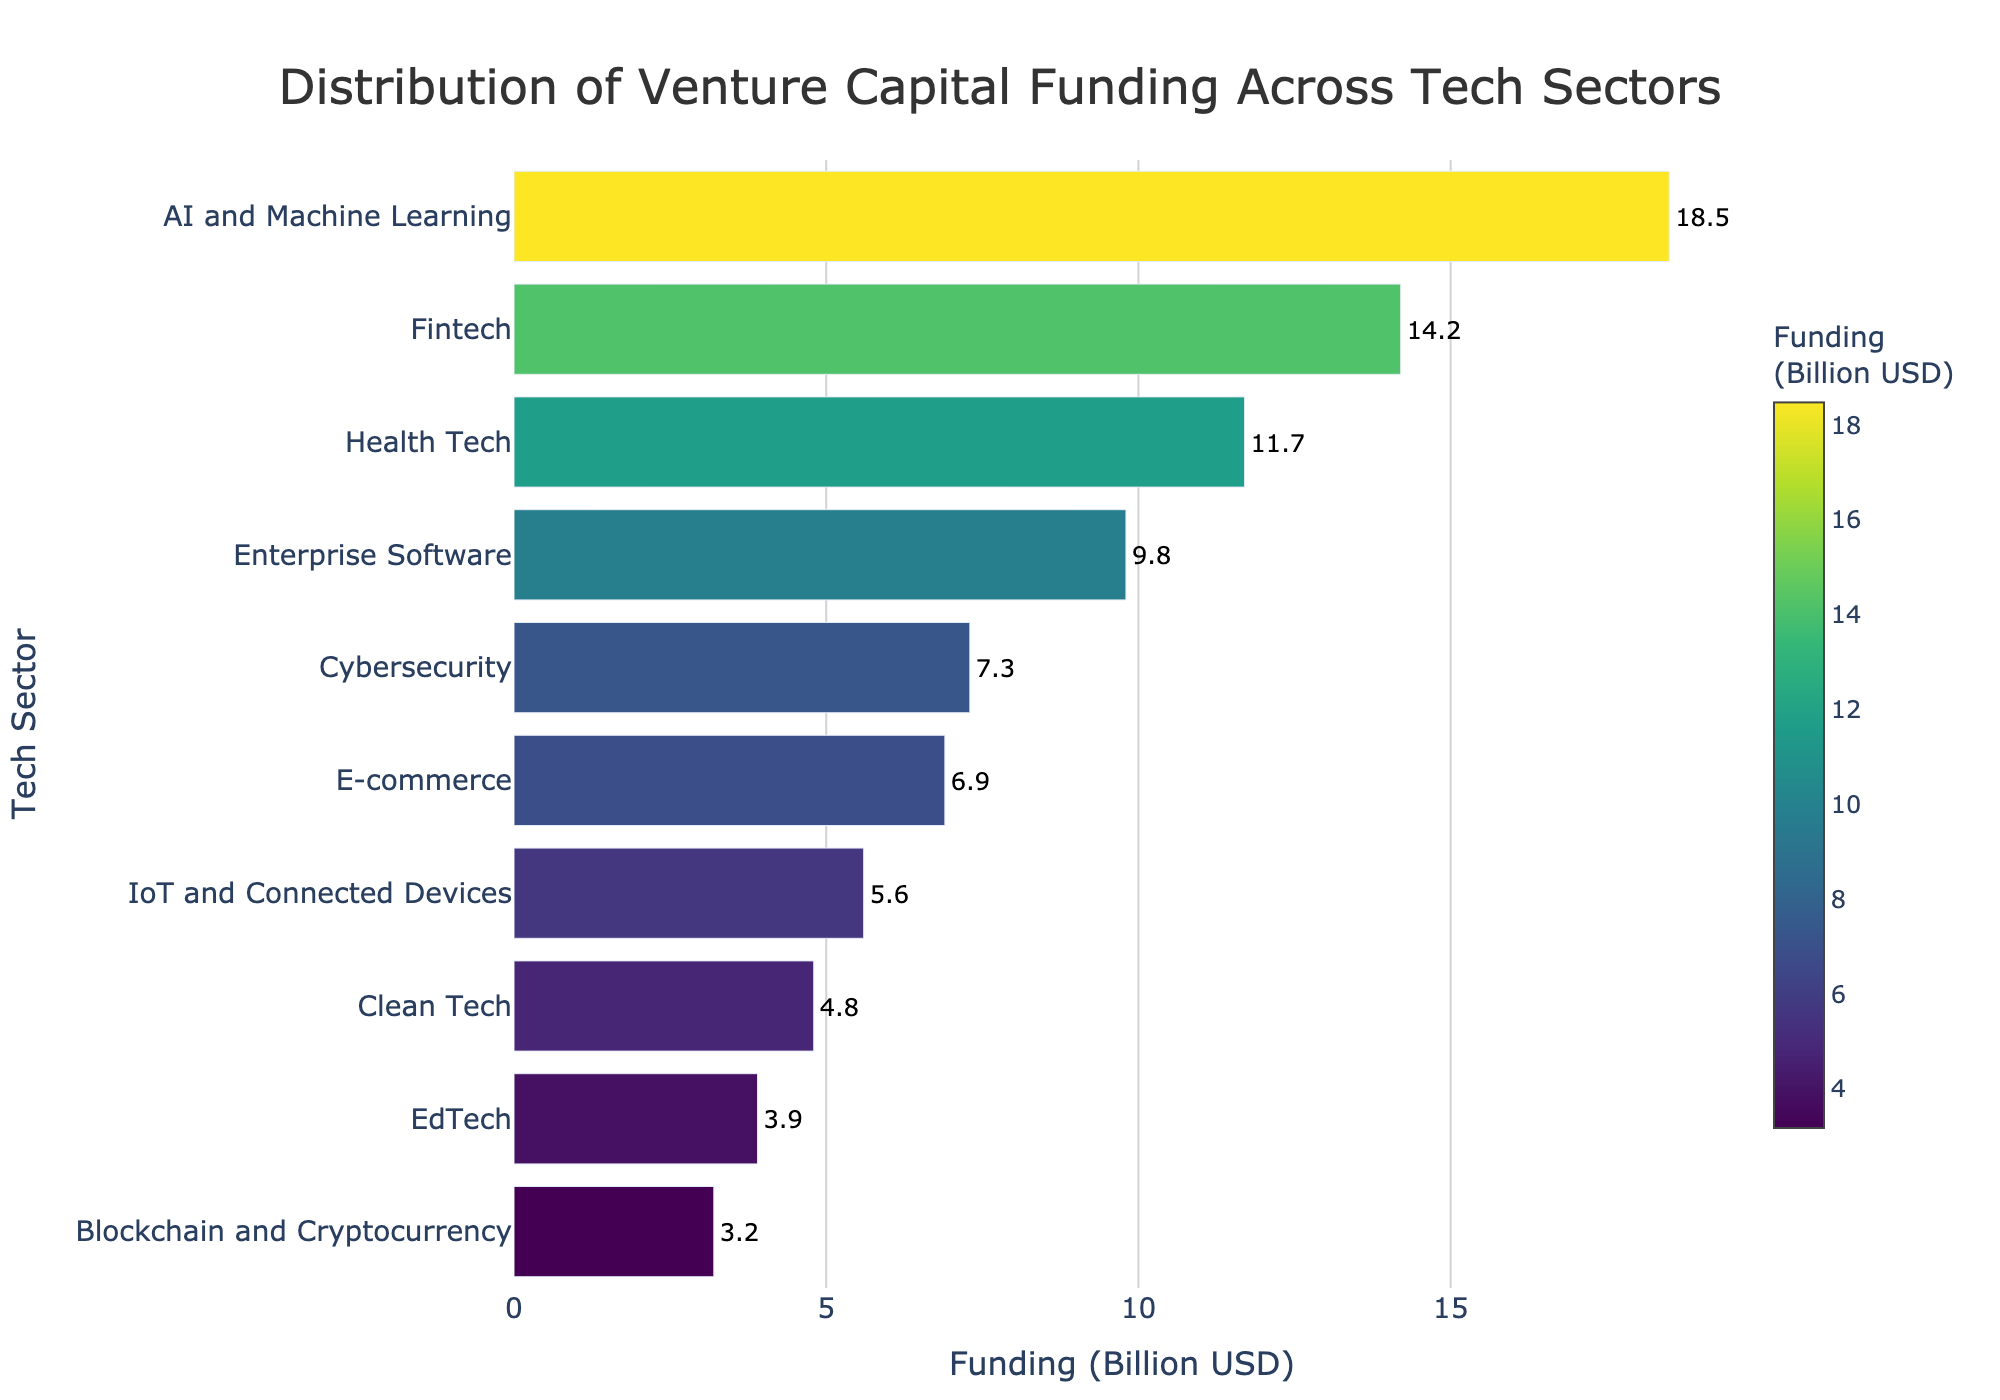What are the tech sectors represented in the figure? To determine the sectors, read the labels on the y-axis of the figure, which lists all the tech sectors.
Answer: AI and Machine Learning, Fintech, Health Tech, Enterprise Software, Cybersecurity, E-commerce, IoT and Connected Devices, Clean Tech, EdTech, Blockchain and Cryptocurrency What's the total venture capital funding across all tech sectors shown in the figure? Add all the funding amounts shown next to each bar. These values are 18.5, 14.2, 11.7, 9.8, 7.3, 6.9, 5.6, 4.8, 3.9, and 3.2 billion USD.
Answer: 85.9 billion USD Which tech sector received the highest amount of venture capital funding? Identify the longest bar on the horizontal bar chart, which corresponds to the tech sector with the highest funding.
Answer: AI and Machine Learning Which tech sector received the lowest amount of venture capital funding? Identify the shortest bar on the horizontal bar chart, which corresponds to the tech sector with the lowest funding.
Answer: Blockchain and Cryptocurrency How much more funding did AI and Machine Learning receive compared to Fintech? Subtract the funding for Fintech from the funding for AI and Machine Learning. AI and Machine Learning has 18.5 billion USD, and Fintech has 14.2 billion USD.
Answer: 4.3 billion USD What is the median funding amount across all the represented tech sectors? First, order the funding amounts: 3.2, 3.9, 4.8, 5.6, 6.9, 7.3, 9.8, 11.7, 14.2, 18.5. The median is the average of the 5th and 6th values in the sorted list.
Answer: 7.1 billion USD How many tech sectors have funding amounts greater than 10 billion USD? Count the bars with funding amounts greater than 10 billion USD by looking at the text values beside the bars.
Answer: 3 sectors What percentage of total funding is represented by the top three funded sectors? Sum the funding amounts for AI and Machine Learning (18.5), Fintech (14.2), and Health Tech (11.7). Then, divide by the total funding (85.9) and multiply by 100 to get the percentage.
Answer: 51.3% Which sectors have a funding difference of less than 1 billion USD between them? Compare adjacent funding amounts to find pairs with a difference of less than 1 billion USD: E-commerce (6.9) and Cybersecurity (7.3); Blockchain and Cryptocurrency (3.2) and EdTech (3.9).
Answer: E-commerce and Cybersecurity; Blockchain and Cryptocurrency and EdTech 